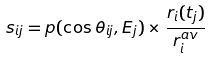<formula> <loc_0><loc_0><loc_500><loc_500>s _ { i j } = p ( \cos \theta _ { i j } , E _ { j } ) \times \frac { r _ { i } ( t _ { j } ) } { r ^ { a v } _ { i } }</formula> 